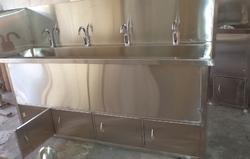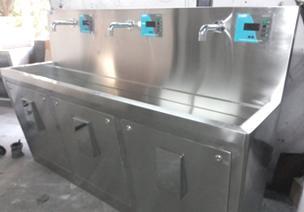The first image is the image on the left, the second image is the image on the right. Evaluate the accuracy of this statement regarding the images: "There are exactly five faucets.". Is it true? Answer yes or no. No. 